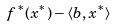Convert formula to latex. <formula><loc_0><loc_0><loc_500><loc_500>f ^ { * } ( x ^ { * } ) - \langle b , x ^ { * } \rangle</formula> 